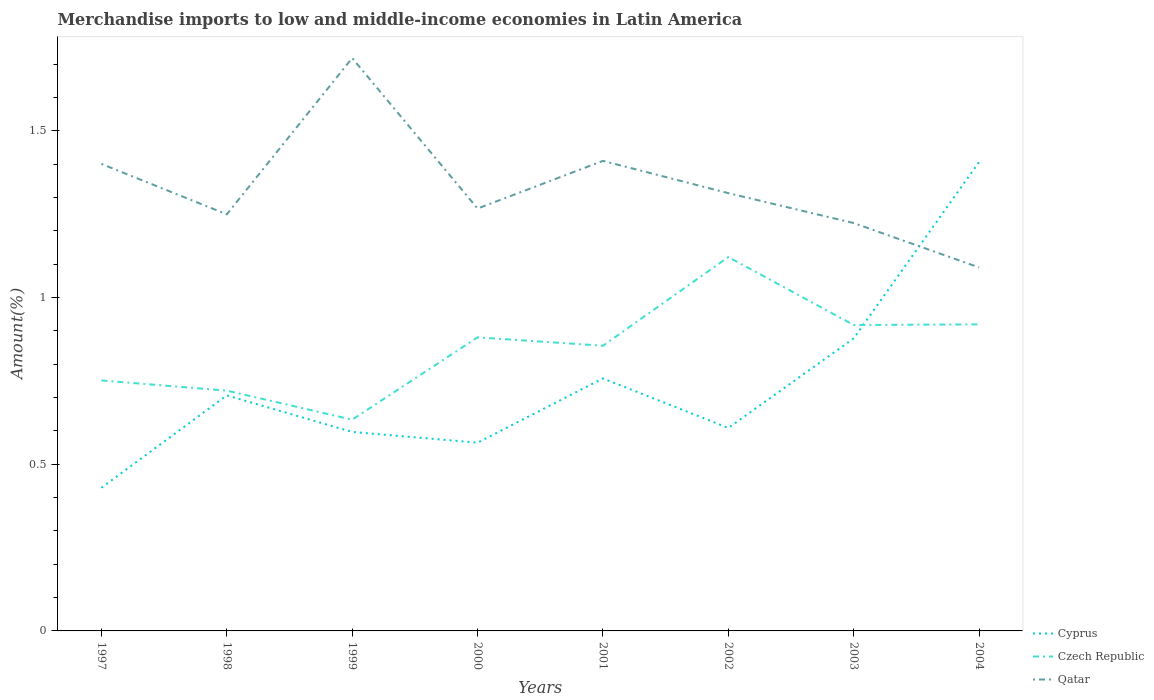Is the number of lines equal to the number of legend labels?
Offer a very short reply. Yes. Across all years, what is the maximum percentage of amount earned from merchandise imports in Qatar?
Offer a terse response. 1.09. What is the total percentage of amount earned from merchandise imports in Czech Republic in the graph?
Provide a succinct answer. -0.17. What is the difference between the highest and the second highest percentage of amount earned from merchandise imports in Cyprus?
Offer a very short reply. 0.98. What is the difference between the highest and the lowest percentage of amount earned from merchandise imports in Czech Republic?
Provide a succinct answer. 5. Is the percentage of amount earned from merchandise imports in Cyprus strictly greater than the percentage of amount earned from merchandise imports in Qatar over the years?
Keep it short and to the point. No. Does the graph contain any zero values?
Provide a succinct answer. No. Where does the legend appear in the graph?
Offer a terse response. Bottom right. How many legend labels are there?
Your response must be concise. 3. How are the legend labels stacked?
Your answer should be compact. Vertical. What is the title of the graph?
Make the answer very short. Merchandise imports to low and middle-income economies in Latin America. What is the label or title of the Y-axis?
Your answer should be very brief. Amount(%). What is the Amount(%) of Cyprus in 1997?
Give a very brief answer. 0.43. What is the Amount(%) in Czech Republic in 1997?
Offer a very short reply. 0.75. What is the Amount(%) of Qatar in 1997?
Your answer should be very brief. 1.4. What is the Amount(%) of Cyprus in 1998?
Give a very brief answer. 0.71. What is the Amount(%) of Czech Republic in 1998?
Your answer should be very brief. 0.72. What is the Amount(%) in Qatar in 1998?
Your answer should be compact. 1.25. What is the Amount(%) of Cyprus in 1999?
Keep it short and to the point. 0.6. What is the Amount(%) in Czech Republic in 1999?
Offer a terse response. 0.63. What is the Amount(%) in Qatar in 1999?
Offer a very short reply. 1.72. What is the Amount(%) in Cyprus in 2000?
Provide a succinct answer. 0.56. What is the Amount(%) of Czech Republic in 2000?
Your answer should be compact. 0.88. What is the Amount(%) of Qatar in 2000?
Give a very brief answer. 1.27. What is the Amount(%) in Cyprus in 2001?
Your answer should be compact. 0.76. What is the Amount(%) in Czech Republic in 2001?
Provide a short and direct response. 0.86. What is the Amount(%) in Qatar in 2001?
Offer a very short reply. 1.41. What is the Amount(%) of Cyprus in 2002?
Make the answer very short. 0.61. What is the Amount(%) in Czech Republic in 2002?
Give a very brief answer. 1.12. What is the Amount(%) in Qatar in 2002?
Offer a terse response. 1.31. What is the Amount(%) in Cyprus in 2003?
Give a very brief answer. 0.88. What is the Amount(%) in Czech Republic in 2003?
Provide a short and direct response. 0.92. What is the Amount(%) in Qatar in 2003?
Provide a succinct answer. 1.22. What is the Amount(%) of Cyprus in 2004?
Give a very brief answer. 1.41. What is the Amount(%) of Czech Republic in 2004?
Provide a succinct answer. 0.92. What is the Amount(%) in Qatar in 2004?
Offer a terse response. 1.09. Across all years, what is the maximum Amount(%) of Cyprus?
Provide a short and direct response. 1.41. Across all years, what is the maximum Amount(%) of Czech Republic?
Make the answer very short. 1.12. Across all years, what is the maximum Amount(%) of Qatar?
Keep it short and to the point. 1.72. Across all years, what is the minimum Amount(%) in Cyprus?
Offer a terse response. 0.43. Across all years, what is the minimum Amount(%) in Czech Republic?
Provide a short and direct response. 0.63. Across all years, what is the minimum Amount(%) in Qatar?
Provide a short and direct response. 1.09. What is the total Amount(%) in Cyprus in the graph?
Offer a very short reply. 5.95. What is the total Amount(%) in Czech Republic in the graph?
Offer a terse response. 6.8. What is the total Amount(%) of Qatar in the graph?
Offer a very short reply. 10.67. What is the difference between the Amount(%) in Cyprus in 1997 and that in 1998?
Keep it short and to the point. -0.28. What is the difference between the Amount(%) in Czech Republic in 1997 and that in 1998?
Offer a terse response. 0.03. What is the difference between the Amount(%) in Qatar in 1997 and that in 1998?
Provide a short and direct response. 0.15. What is the difference between the Amount(%) in Cyprus in 1997 and that in 1999?
Your answer should be compact. -0.17. What is the difference between the Amount(%) in Czech Republic in 1997 and that in 1999?
Provide a short and direct response. 0.12. What is the difference between the Amount(%) of Qatar in 1997 and that in 1999?
Your answer should be compact. -0.32. What is the difference between the Amount(%) of Cyprus in 1997 and that in 2000?
Your answer should be very brief. -0.14. What is the difference between the Amount(%) of Czech Republic in 1997 and that in 2000?
Give a very brief answer. -0.13. What is the difference between the Amount(%) in Qatar in 1997 and that in 2000?
Give a very brief answer. 0.13. What is the difference between the Amount(%) of Cyprus in 1997 and that in 2001?
Keep it short and to the point. -0.33. What is the difference between the Amount(%) in Czech Republic in 1997 and that in 2001?
Give a very brief answer. -0.1. What is the difference between the Amount(%) in Qatar in 1997 and that in 2001?
Make the answer very short. -0.01. What is the difference between the Amount(%) in Cyprus in 1997 and that in 2002?
Your answer should be very brief. -0.18. What is the difference between the Amount(%) of Czech Republic in 1997 and that in 2002?
Provide a short and direct response. -0.37. What is the difference between the Amount(%) of Qatar in 1997 and that in 2002?
Make the answer very short. 0.09. What is the difference between the Amount(%) of Cyprus in 1997 and that in 2003?
Ensure brevity in your answer.  -0.45. What is the difference between the Amount(%) in Czech Republic in 1997 and that in 2003?
Provide a succinct answer. -0.17. What is the difference between the Amount(%) of Qatar in 1997 and that in 2003?
Keep it short and to the point. 0.18. What is the difference between the Amount(%) of Cyprus in 1997 and that in 2004?
Offer a very short reply. -0.98. What is the difference between the Amount(%) in Czech Republic in 1997 and that in 2004?
Ensure brevity in your answer.  -0.17. What is the difference between the Amount(%) in Qatar in 1997 and that in 2004?
Ensure brevity in your answer.  0.31. What is the difference between the Amount(%) in Cyprus in 1998 and that in 1999?
Provide a short and direct response. 0.11. What is the difference between the Amount(%) of Czech Republic in 1998 and that in 1999?
Provide a short and direct response. 0.09. What is the difference between the Amount(%) of Qatar in 1998 and that in 1999?
Your answer should be very brief. -0.47. What is the difference between the Amount(%) in Cyprus in 1998 and that in 2000?
Your answer should be very brief. 0.14. What is the difference between the Amount(%) in Czech Republic in 1998 and that in 2000?
Ensure brevity in your answer.  -0.16. What is the difference between the Amount(%) of Qatar in 1998 and that in 2000?
Your response must be concise. -0.02. What is the difference between the Amount(%) of Cyprus in 1998 and that in 2001?
Offer a terse response. -0.05. What is the difference between the Amount(%) of Czech Republic in 1998 and that in 2001?
Keep it short and to the point. -0.13. What is the difference between the Amount(%) of Qatar in 1998 and that in 2001?
Offer a terse response. -0.16. What is the difference between the Amount(%) in Cyprus in 1998 and that in 2002?
Provide a succinct answer. 0.1. What is the difference between the Amount(%) in Czech Republic in 1998 and that in 2002?
Provide a succinct answer. -0.4. What is the difference between the Amount(%) in Qatar in 1998 and that in 2002?
Your answer should be very brief. -0.06. What is the difference between the Amount(%) of Cyprus in 1998 and that in 2003?
Make the answer very short. -0.17. What is the difference between the Amount(%) in Czech Republic in 1998 and that in 2003?
Make the answer very short. -0.2. What is the difference between the Amount(%) of Qatar in 1998 and that in 2003?
Make the answer very short. 0.03. What is the difference between the Amount(%) in Cyprus in 1998 and that in 2004?
Keep it short and to the point. -0.7. What is the difference between the Amount(%) in Czech Republic in 1998 and that in 2004?
Ensure brevity in your answer.  -0.2. What is the difference between the Amount(%) in Qatar in 1998 and that in 2004?
Offer a terse response. 0.16. What is the difference between the Amount(%) in Cyprus in 1999 and that in 2000?
Provide a short and direct response. 0.03. What is the difference between the Amount(%) of Czech Republic in 1999 and that in 2000?
Offer a very short reply. -0.25. What is the difference between the Amount(%) of Qatar in 1999 and that in 2000?
Provide a succinct answer. 0.45. What is the difference between the Amount(%) in Cyprus in 1999 and that in 2001?
Give a very brief answer. -0.16. What is the difference between the Amount(%) in Czech Republic in 1999 and that in 2001?
Your response must be concise. -0.22. What is the difference between the Amount(%) in Qatar in 1999 and that in 2001?
Offer a terse response. 0.31. What is the difference between the Amount(%) in Cyprus in 1999 and that in 2002?
Provide a succinct answer. -0.01. What is the difference between the Amount(%) in Czech Republic in 1999 and that in 2002?
Your answer should be compact. -0.49. What is the difference between the Amount(%) of Qatar in 1999 and that in 2002?
Keep it short and to the point. 0.41. What is the difference between the Amount(%) in Cyprus in 1999 and that in 2003?
Your answer should be very brief. -0.28. What is the difference between the Amount(%) in Czech Republic in 1999 and that in 2003?
Offer a very short reply. -0.28. What is the difference between the Amount(%) of Qatar in 1999 and that in 2003?
Make the answer very short. 0.49. What is the difference between the Amount(%) of Cyprus in 1999 and that in 2004?
Make the answer very short. -0.81. What is the difference between the Amount(%) of Czech Republic in 1999 and that in 2004?
Keep it short and to the point. -0.29. What is the difference between the Amount(%) in Qatar in 1999 and that in 2004?
Offer a very short reply. 0.63. What is the difference between the Amount(%) of Cyprus in 2000 and that in 2001?
Provide a short and direct response. -0.19. What is the difference between the Amount(%) of Czech Republic in 2000 and that in 2001?
Offer a very short reply. 0.03. What is the difference between the Amount(%) of Qatar in 2000 and that in 2001?
Offer a terse response. -0.14. What is the difference between the Amount(%) of Cyprus in 2000 and that in 2002?
Offer a very short reply. -0.04. What is the difference between the Amount(%) of Czech Republic in 2000 and that in 2002?
Provide a succinct answer. -0.24. What is the difference between the Amount(%) of Qatar in 2000 and that in 2002?
Make the answer very short. -0.05. What is the difference between the Amount(%) of Cyprus in 2000 and that in 2003?
Offer a very short reply. -0.31. What is the difference between the Amount(%) in Czech Republic in 2000 and that in 2003?
Your answer should be very brief. -0.04. What is the difference between the Amount(%) of Qatar in 2000 and that in 2003?
Offer a very short reply. 0.04. What is the difference between the Amount(%) in Cyprus in 2000 and that in 2004?
Your response must be concise. -0.84. What is the difference between the Amount(%) of Czech Republic in 2000 and that in 2004?
Give a very brief answer. -0.04. What is the difference between the Amount(%) of Qatar in 2000 and that in 2004?
Provide a short and direct response. 0.18. What is the difference between the Amount(%) of Cyprus in 2001 and that in 2002?
Your response must be concise. 0.15. What is the difference between the Amount(%) in Czech Republic in 2001 and that in 2002?
Provide a short and direct response. -0.27. What is the difference between the Amount(%) of Qatar in 2001 and that in 2002?
Keep it short and to the point. 0.1. What is the difference between the Amount(%) of Cyprus in 2001 and that in 2003?
Your response must be concise. -0.12. What is the difference between the Amount(%) of Czech Republic in 2001 and that in 2003?
Ensure brevity in your answer.  -0.06. What is the difference between the Amount(%) of Qatar in 2001 and that in 2003?
Your answer should be very brief. 0.19. What is the difference between the Amount(%) in Cyprus in 2001 and that in 2004?
Your response must be concise. -0.65. What is the difference between the Amount(%) in Czech Republic in 2001 and that in 2004?
Your response must be concise. -0.06. What is the difference between the Amount(%) in Qatar in 2001 and that in 2004?
Your answer should be compact. 0.32. What is the difference between the Amount(%) in Cyprus in 2002 and that in 2003?
Ensure brevity in your answer.  -0.27. What is the difference between the Amount(%) of Czech Republic in 2002 and that in 2003?
Keep it short and to the point. 0.2. What is the difference between the Amount(%) of Qatar in 2002 and that in 2003?
Offer a very short reply. 0.09. What is the difference between the Amount(%) in Cyprus in 2002 and that in 2004?
Give a very brief answer. -0.8. What is the difference between the Amount(%) of Czech Republic in 2002 and that in 2004?
Offer a very short reply. 0.2. What is the difference between the Amount(%) in Qatar in 2002 and that in 2004?
Ensure brevity in your answer.  0.22. What is the difference between the Amount(%) of Cyprus in 2003 and that in 2004?
Give a very brief answer. -0.53. What is the difference between the Amount(%) in Czech Republic in 2003 and that in 2004?
Keep it short and to the point. -0. What is the difference between the Amount(%) in Qatar in 2003 and that in 2004?
Your answer should be compact. 0.13. What is the difference between the Amount(%) in Cyprus in 1997 and the Amount(%) in Czech Republic in 1998?
Keep it short and to the point. -0.29. What is the difference between the Amount(%) of Cyprus in 1997 and the Amount(%) of Qatar in 1998?
Make the answer very short. -0.82. What is the difference between the Amount(%) of Czech Republic in 1997 and the Amount(%) of Qatar in 1998?
Offer a terse response. -0.5. What is the difference between the Amount(%) in Cyprus in 1997 and the Amount(%) in Czech Republic in 1999?
Provide a succinct answer. -0.2. What is the difference between the Amount(%) in Cyprus in 1997 and the Amount(%) in Qatar in 1999?
Ensure brevity in your answer.  -1.29. What is the difference between the Amount(%) of Czech Republic in 1997 and the Amount(%) of Qatar in 1999?
Ensure brevity in your answer.  -0.97. What is the difference between the Amount(%) in Cyprus in 1997 and the Amount(%) in Czech Republic in 2000?
Offer a very short reply. -0.45. What is the difference between the Amount(%) in Cyprus in 1997 and the Amount(%) in Qatar in 2000?
Your answer should be compact. -0.84. What is the difference between the Amount(%) in Czech Republic in 1997 and the Amount(%) in Qatar in 2000?
Offer a terse response. -0.52. What is the difference between the Amount(%) in Cyprus in 1997 and the Amount(%) in Czech Republic in 2001?
Keep it short and to the point. -0.43. What is the difference between the Amount(%) of Cyprus in 1997 and the Amount(%) of Qatar in 2001?
Your answer should be compact. -0.98. What is the difference between the Amount(%) of Czech Republic in 1997 and the Amount(%) of Qatar in 2001?
Ensure brevity in your answer.  -0.66. What is the difference between the Amount(%) of Cyprus in 1997 and the Amount(%) of Czech Republic in 2002?
Provide a succinct answer. -0.69. What is the difference between the Amount(%) in Cyprus in 1997 and the Amount(%) in Qatar in 2002?
Your answer should be compact. -0.88. What is the difference between the Amount(%) of Czech Republic in 1997 and the Amount(%) of Qatar in 2002?
Your answer should be very brief. -0.56. What is the difference between the Amount(%) in Cyprus in 1997 and the Amount(%) in Czech Republic in 2003?
Ensure brevity in your answer.  -0.49. What is the difference between the Amount(%) in Cyprus in 1997 and the Amount(%) in Qatar in 2003?
Your answer should be very brief. -0.79. What is the difference between the Amount(%) in Czech Republic in 1997 and the Amount(%) in Qatar in 2003?
Your answer should be very brief. -0.47. What is the difference between the Amount(%) in Cyprus in 1997 and the Amount(%) in Czech Republic in 2004?
Your answer should be compact. -0.49. What is the difference between the Amount(%) in Cyprus in 1997 and the Amount(%) in Qatar in 2004?
Provide a succinct answer. -0.66. What is the difference between the Amount(%) of Czech Republic in 1997 and the Amount(%) of Qatar in 2004?
Make the answer very short. -0.34. What is the difference between the Amount(%) of Cyprus in 1998 and the Amount(%) of Czech Republic in 1999?
Offer a terse response. 0.07. What is the difference between the Amount(%) in Cyprus in 1998 and the Amount(%) in Qatar in 1999?
Your answer should be very brief. -1.01. What is the difference between the Amount(%) of Czech Republic in 1998 and the Amount(%) of Qatar in 1999?
Offer a very short reply. -1. What is the difference between the Amount(%) in Cyprus in 1998 and the Amount(%) in Czech Republic in 2000?
Make the answer very short. -0.17. What is the difference between the Amount(%) in Cyprus in 1998 and the Amount(%) in Qatar in 2000?
Make the answer very short. -0.56. What is the difference between the Amount(%) in Czech Republic in 1998 and the Amount(%) in Qatar in 2000?
Your answer should be very brief. -0.55. What is the difference between the Amount(%) of Cyprus in 1998 and the Amount(%) of Czech Republic in 2001?
Keep it short and to the point. -0.15. What is the difference between the Amount(%) of Cyprus in 1998 and the Amount(%) of Qatar in 2001?
Provide a succinct answer. -0.7. What is the difference between the Amount(%) in Czech Republic in 1998 and the Amount(%) in Qatar in 2001?
Your answer should be compact. -0.69. What is the difference between the Amount(%) in Cyprus in 1998 and the Amount(%) in Czech Republic in 2002?
Keep it short and to the point. -0.41. What is the difference between the Amount(%) of Cyprus in 1998 and the Amount(%) of Qatar in 2002?
Offer a very short reply. -0.61. What is the difference between the Amount(%) in Czech Republic in 1998 and the Amount(%) in Qatar in 2002?
Offer a very short reply. -0.59. What is the difference between the Amount(%) in Cyprus in 1998 and the Amount(%) in Czech Republic in 2003?
Offer a very short reply. -0.21. What is the difference between the Amount(%) of Cyprus in 1998 and the Amount(%) of Qatar in 2003?
Your answer should be compact. -0.52. What is the difference between the Amount(%) of Czech Republic in 1998 and the Amount(%) of Qatar in 2003?
Keep it short and to the point. -0.5. What is the difference between the Amount(%) in Cyprus in 1998 and the Amount(%) in Czech Republic in 2004?
Your response must be concise. -0.21. What is the difference between the Amount(%) in Cyprus in 1998 and the Amount(%) in Qatar in 2004?
Ensure brevity in your answer.  -0.38. What is the difference between the Amount(%) of Czech Republic in 1998 and the Amount(%) of Qatar in 2004?
Ensure brevity in your answer.  -0.37. What is the difference between the Amount(%) of Cyprus in 1999 and the Amount(%) of Czech Republic in 2000?
Your answer should be very brief. -0.28. What is the difference between the Amount(%) in Cyprus in 1999 and the Amount(%) in Qatar in 2000?
Provide a short and direct response. -0.67. What is the difference between the Amount(%) of Czech Republic in 1999 and the Amount(%) of Qatar in 2000?
Your answer should be compact. -0.63. What is the difference between the Amount(%) of Cyprus in 1999 and the Amount(%) of Czech Republic in 2001?
Your response must be concise. -0.26. What is the difference between the Amount(%) in Cyprus in 1999 and the Amount(%) in Qatar in 2001?
Give a very brief answer. -0.81. What is the difference between the Amount(%) in Czech Republic in 1999 and the Amount(%) in Qatar in 2001?
Your response must be concise. -0.78. What is the difference between the Amount(%) of Cyprus in 1999 and the Amount(%) of Czech Republic in 2002?
Provide a succinct answer. -0.52. What is the difference between the Amount(%) in Cyprus in 1999 and the Amount(%) in Qatar in 2002?
Offer a terse response. -0.72. What is the difference between the Amount(%) in Czech Republic in 1999 and the Amount(%) in Qatar in 2002?
Offer a terse response. -0.68. What is the difference between the Amount(%) in Cyprus in 1999 and the Amount(%) in Czech Republic in 2003?
Make the answer very short. -0.32. What is the difference between the Amount(%) of Cyprus in 1999 and the Amount(%) of Qatar in 2003?
Your answer should be very brief. -0.63. What is the difference between the Amount(%) of Czech Republic in 1999 and the Amount(%) of Qatar in 2003?
Provide a short and direct response. -0.59. What is the difference between the Amount(%) of Cyprus in 1999 and the Amount(%) of Czech Republic in 2004?
Ensure brevity in your answer.  -0.32. What is the difference between the Amount(%) in Cyprus in 1999 and the Amount(%) in Qatar in 2004?
Make the answer very short. -0.49. What is the difference between the Amount(%) in Czech Republic in 1999 and the Amount(%) in Qatar in 2004?
Your answer should be very brief. -0.46. What is the difference between the Amount(%) in Cyprus in 2000 and the Amount(%) in Czech Republic in 2001?
Ensure brevity in your answer.  -0.29. What is the difference between the Amount(%) in Cyprus in 2000 and the Amount(%) in Qatar in 2001?
Your answer should be very brief. -0.84. What is the difference between the Amount(%) in Czech Republic in 2000 and the Amount(%) in Qatar in 2001?
Ensure brevity in your answer.  -0.53. What is the difference between the Amount(%) of Cyprus in 2000 and the Amount(%) of Czech Republic in 2002?
Provide a short and direct response. -0.56. What is the difference between the Amount(%) of Cyprus in 2000 and the Amount(%) of Qatar in 2002?
Offer a terse response. -0.75. What is the difference between the Amount(%) of Czech Republic in 2000 and the Amount(%) of Qatar in 2002?
Give a very brief answer. -0.43. What is the difference between the Amount(%) of Cyprus in 2000 and the Amount(%) of Czech Republic in 2003?
Offer a terse response. -0.35. What is the difference between the Amount(%) of Cyprus in 2000 and the Amount(%) of Qatar in 2003?
Your answer should be compact. -0.66. What is the difference between the Amount(%) of Czech Republic in 2000 and the Amount(%) of Qatar in 2003?
Provide a succinct answer. -0.34. What is the difference between the Amount(%) in Cyprus in 2000 and the Amount(%) in Czech Republic in 2004?
Make the answer very short. -0.35. What is the difference between the Amount(%) of Cyprus in 2000 and the Amount(%) of Qatar in 2004?
Your answer should be very brief. -0.53. What is the difference between the Amount(%) in Czech Republic in 2000 and the Amount(%) in Qatar in 2004?
Give a very brief answer. -0.21. What is the difference between the Amount(%) of Cyprus in 2001 and the Amount(%) of Czech Republic in 2002?
Offer a terse response. -0.36. What is the difference between the Amount(%) of Cyprus in 2001 and the Amount(%) of Qatar in 2002?
Offer a terse response. -0.56. What is the difference between the Amount(%) in Czech Republic in 2001 and the Amount(%) in Qatar in 2002?
Ensure brevity in your answer.  -0.46. What is the difference between the Amount(%) of Cyprus in 2001 and the Amount(%) of Czech Republic in 2003?
Your response must be concise. -0.16. What is the difference between the Amount(%) in Cyprus in 2001 and the Amount(%) in Qatar in 2003?
Make the answer very short. -0.47. What is the difference between the Amount(%) of Czech Republic in 2001 and the Amount(%) of Qatar in 2003?
Offer a terse response. -0.37. What is the difference between the Amount(%) of Cyprus in 2001 and the Amount(%) of Czech Republic in 2004?
Ensure brevity in your answer.  -0.16. What is the difference between the Amount(%) in Cyprus in 2001 and the Amount(%) in Qatar in 2004?
Provide a succinct answer. -0.33. What is the difference between the Amount(%) in Czech Republic in 2001 and the Amount(%) in Qatar in 2004?
Make the answer very short. -0.23. What is the difference between the Amount(%) in Cyprus in 2002 and the Amount(%) in Czech Republic in 2003?
Your answer should be compact. -0.31. What is the difference between the Amount(%) in Cyprus in 2002 and the Amount(%) in Qatar in 2003?
Offer a very short reply. -0.61. What is the difference between the Amount(%) in Czech Republic in 2002 and the Amount(%) in Qatar in 2003?
Make the answer very short. -0.1. What is the difference between the Amount(%) in Cyprus in 2002 and the Amount(%) in Czech Republic in 2004?
Your answer should be very brief. -0.31. What is the difference between the Amount(%) in Cyprus in 2002 and the Amount(%) in Qatar in 2004?
Give a very brief answer. -0.48. What is the difference between the Amount(%) in Czech Republic in 2002 and the Amount(%) in Qatar in 2004?
Your answer should be compact. 0.03. What is the difference between the Amount(%) of Cyprus in 2003 and the Amount(%) of Czech Republic in 2004?
Offer a very short reply. -0.04. What is the difference between the Amount(%) in Cyprus in 2003 and the Amount(%) in Qatar in 2004?
Keep it short and to the point. -0.21. What is the difference between the Amount(%) of Czech Republic in 2003 and the Amount(%) of Qatar in 2004?
Provide a succinct answer. -0.17. What is the average Amount(%) in Cyprus per year?
Offer a terse response. 0.74. What is the average Amount(%) in Czech Republic per year?
Your response must be concise. 0.85. What is the average Amount(%) of Qatar per year?
Your response must be concise. 1.33. In the year 1997, what is the difference between the Amount(%) of Cyprus and Amount(%) of Czech Republic?
Make the answer very short. -0.32. In the year 1997, what is the difference between the Amount(%) of Cyprus and Amount(%) of Qatar?
Keep it short and to the point. -0.97. In the year 1997, what is the difference between the Amount(%) of Czech Republic and Amount(%) of Qatar?
Your answer should be very brief. -0.65. In the year 1998, what is the difference between the Amount(%) of Cyprus and Amount(%) of Czech Republic?
Your response must be concise. -0.01. In the year 1998, what is the difference between the Amount(%) of Cyprus and Amount(%) of Qatar?
Make the answer very short. -0.54. In the year 1998, what is the difference between the Amount(%) of Czech Republic and Amount(%) of Qatar?
Offer a terse response. -0.53. In the year 1999, what is the difference between the Amount(%) of Cyprus and Amount(%) of Czech Republic?
Keep it short and to the point. -0.04. In the year 1999, what is the difference between the Amount(%) of Cyprus and Amount(%) of Qatar?
Provide a succinct answer. -1.12. In the year 1999, what is the difference between the Amount(%) of Czech Republic and Amount(%) of Qatar?
Keep it short and to the point. -1.08. In the year 2000, what is the difference between the Amount(%) in Cyprus and Amount(%) in Czech Republic?
Provide a succinct answer. -0.32. In the year 2000, what is the difference between the Amount(%) of Cyprus and Amount(%) of Qatar?
Offer a terse response. -0.7. In the year 2000, what is the difference between the Amount(%) of Czech Republic and Amount(%) of Qatar?
Your answer should be very brief. -0.39. In the year 2001, what is the difference between the Amount(%) of Cyprus and Amount(%) of Czech Republic?
Your response must be concise. -0.1. In the year 2001, what is the difference between the Amount(%) in Cyprus and Amount(%) in Qatar?
Give a very brief answer. -0.65. In the year 2001, what is the difference between the Amount(%) of Czech Republic and Amount(%) of Qatar?
Provide a short and direct response. -0.55. In the year 2002, what is the difference between the Amount(%) in Cyprus and Amount(%) in Czech Republic?
Offer a terse response. -0.51. In the year 2002, what is the difference between the Amount(%) in Cyprus and Amount(%) in Qatar?
Offer a terse response. -0.7. In the year 2002, what is the difference between the Amount(%) in Czech Republic and Amount(%) in Qatar?
Your answer should be compact. -0.19. In the year 2003, what is the difference between the Amount(%) of Cyprus and Amount(%) of Czech Republic?
Offer a terse response. -0.04. In the year 2003, what is the difference between the Amount(%) of Cyprus and Amount(%) of Qatar?
Offer a terse response. -0.35. In the year 2003, what is the difference between the Amount(%) in Czech Republic and Amount(%) in Qatar?
Your response must be concise. -0.31. In the year 2004, what is the difference between the Amount(%) of Cyprus and Amount(%) of Czech Republic?
Offer a terse response. 0.49. In the year 2004, what is the difference between the Amount(%) in Cyprus and Amount(%) in Qatar?
Give a very brief answer. 0.32. In the year 2004, what is the difference between the Amount(%) in Czech Republic and Amount(%) in Qatar?
Provide a succinct answer. -0.17. What is the ratio of the Amount(%) in Cyprus in 1997 to that in 1998?
Give a very brief answer. 0.61. What is the ratio of the Amount(%) in Czech Republic in 1997 to that in 1998?
Ensure brevity in your answer.  1.04. What is the ratio of the Amount(%) in Qatar in 1997 to that in 1998?
Provide a succinct answer. 1.12. What is the ratio of the Amount(%) of Cyprus in 1997 to that in 1999?
Make the answer very short. 0.72. What is the ratio of the Amount(%) of Czech Republic in 1997 to that in 1999?
Provide a short and direct response. 1.19. What is the ratio of the Amount(%) of Qatar in 1997 to that in 1999?
Provide a short and direct response. 0.82. What is the ratio of the Amount(%) in Cyprus in 1997 to that in 2000?
Give a very brief answer. 0.76. What is the ratio of the Amount(%) of Czech Republic in 1997 to that in 2000?
Keep it short and to the point. 0.85. What is the ratio of the Amount(%) of Qatar in 1997 to that in 2000?
Offer a terse response. 1.11. What is the ratio of the Amount(%) of Cyprus in 1997 to that in 2001?
Offer a very short reply. 0.57. What is the ratio of the Amount(%) of Czech Republic in 1997 to that in 2001?
Provide a succinct answer. 0.88. What is the ratio of the Amount(%) in Cyprus in 1997 to that in 2002?
Give a very brief answer. 0.71. What is the ratio of the Amount(%) in Czech Republic in 1997 to that in 2002?
Offer a terse response. 0.67. What is the ratio of the Amount(%) of Qatar in 1997 to that in 2002?
Keep it short and to the point. 1.07. What is the ratio of the Amount(%) in Cyprus in 1997 to that in 2003?
Give a very brief answer. 0.49. What is the ratio of the Amount(%) in Czech Republic in 1997 to that in 2003?
Offer a very short reply. 0.82. What is the ratio of the Amount(%) in Qatar in 1997 to that in 2003?
Your response must be concise. 1.15. What is the ratio of the Amount(%) of Cyprus in 1997 to that in 2004?
Offer a very short reply. 0.31. What is the ratio of the Amount(%) in Czech Republic in 1997 to that in 2004?
Your response must be concise. 0.82. What is the ratio of the Amount(%) in Qatar in 1997 to that in 2004?
Offer a terse response. 1.28. What is the ratio of the Amount(%) in Cyprus in 1998 to that in 1999?
Provide a short and direct response. 1.18. What is the ratio of the Amount(%) of Czech Republic in 1998 to that in 1999?
Your answer should be very brief. 1.14. What is the ratio of the Amount(%) in Qatar in 1998 to that in 1999?
Give a very brief answer. 0.73. What is the ratio of the Amount(%) of Cyprus in 1998 to that in 2000?
Keep it short and to the point. 1.25. What is the ratio of the Amount(%) in Czech Republic in 1998 to that in 2000?
Your answer should be compact. 0.82. What is the ratio of the Amount(%) in Qatar in 1998 to that in 2000?
Ensure brevity in your answer.  0.99. What is the ratio of the Amount(%) of Cyprus in 1998 to that in 2001?
Give a very brief answer. 0.93. What is the ratio of the Amount(%) of Czech Republic in 1998 to that in 2001?
Provide a succinct answer. 0.84. What is the ratio of the Amount(%) in Qatar in 1998 to that in 2001?
Give a very brief answer. 0.89. What is the ratio of the Amount(%) of Cyprus in 1998 to that in 2002?
Keep it short and to the point. 1.16. What is the ratio of the Amount(%) in Czech Republic in 1998 to that in 2002?
Your response must be concise. 0.64. What is the ratio of the Amount(%) in Qatar in 1998 to that in 2002?
Keep it short and to the point. 0.95. What is the ratio of the Amount(%) in Cyprus in 1998 to that in 2003?
Offer a very short reply. 0.81. What is the ratio of the Amount(%) in Czech Republic in 1998 to that in 2003?
Your response must be concise. 0.79. What is the ratio of the Amount(%) of Qatar in 1998 to that in 2003?
Give a very brief answer. 1.02. What is the ratio of the Amount(%) in Cyprus in 1998 to that in 2004?
Your response must be concise. 0.5. What is the ratio of the Amount(%) in Czech Republic in 1998 to that in 2004?
Offer a very short reply. 0.78. What is the ratio of the Amount(%) in Qatar in 1998 to that in 2004?
Offer a very short reply. 1.15. What is the ratio of the Amount(%) of Cyprus in 1999 to that in 2000?
Ensure brevity in your answer.  1.06. What is the ratio of the Amount(%) in Czech Republic in 1999 to that in 2000?
Keep it short and to the point. 0.72. What is the ratio of the Amount(%) in Qatar in 1999 to that in 2000?
Your response must be concise. 1.36. What is the ratio of the Amount(%) in Cyprus in 1999 to that in 2001?
Offer a very short reply. 0.79. What is the ratio of the Amount(%) of Czech Republic in 1999 to that in 2001?
Ensure brevity in your answer.  0.74. What is the ratio of the Amount(%) of Qatar in 1999 to that in 2001?
Provide a succinct answer. 1.22. What is the ratio of the Amount(%) in Cyprus in 1999 to that in 2002?
Ensure brevity in your answer.  0.98. What is the ratio of the Amount(%) of Czech Republic in 1999 to that in 2002?
Offer a terse response. 0.56. What is the ratio of the Amount(%) of Qatar in 1999 to that in 2002?
Ensure brevity in your answer.  1.31. What is the ratio of the Amount(%) in Cyprus in 1999 to that in 2003?
Offer a terse response. 0.68. What is the ratio of the Amount(%) in Czech Republic in 1999 to that in 2003?
Provide a short and direct response. 0.69. What is the ratio of the Amount(%) in Qatar in 1999 to that in 2003?
Your answer should be very brief. 1.4. What is the ratio of the Amount(%) in Cyprus in 1999 to that in 2004?
Provide a short and direct response. 0.42. What is the ratio of the Amount(%) of Czech Republic in 1999 to that in 2004?
Offer a very short reply. 0.69. What is the ratio of the Amount(%) in Qatar in 1999 to that in 2004?
Provide a succinct answer. 1.58. What is the ratio of the Amount(%) in Cyprus in 2000 to that in 2001?
Your response must be concise. 0.75. What is the ratio of the Amount(%) of Czech Republic in 2000 to that in 2001?
Provide a succinct answer. 1.03. What is the ratio of the Amount(%) of Qatar in 2000 to that in 2001?
Your response must be concise. 0.9. What is the ratio of the Amount(%) in Cyprus in 2000 to that in 2002?
Provide a succinct answer. 0.93. What is the ratio of the Amount(%) of Czech Republic in 2000 to that in 2002?
Ensure brevity in your answer.  0.79. What is the ratio of the Amount(%) of Qatar in 2000 to that in 2002?
Your answer should be very brief. 0.96. What is the ratio of the Amount(%) of Cyprus in 2000 to that in 2003?
Offer a terse response. 0.64. What is the ratio of the Amount(%) in Czech Republic in 2000 to that in 2003?
Offer a terse response. 0.96. What is the ratio of the Amount(%) in Qatar in 2000 to that in 2003?
Give a very brief answer. 1.04. What is the ratio of the Amount(%) in Cyprus in 2000 to that in 2004?
Your response must be concise. 0.4. What is the ratio of the Amount(%) of Czech Republic in 2000 to that in 2004?
Ensure brevity in your answer.  0.96. What is the ratio of the Amount(%) in Qatar in 2000 to that in 2004?
Ensure brevity in your answer.  1.16. What is the ratio of the Amount(%) of Cyprus in 2001 to that in 2002?
Keep it short and to the point. 1.24. What is the ratio of the Amount(%) of Czech Republic in 2001 to that in 2002?
Provide a succinct answer. 0.76. What is the ratio of the Amount(%) of Qatar in 2001 to that in 2002?
Your answer should be very brief. 1.07. What is the ratio of the Amount(%) in Cyprus in 2001 to that in 2003?
Keep it short and to the point. 0.86. What is the ratio of the Amount(%) in Czech Republic in 2001 to that in 2003?
Offer a very short reply. 0.93. What is the ratio of the Amount(%) of Qatar in 2001 to that in 2003?
Your answer should be very brief. 1.15. What is the ratio of the Amount(%) in Cyprus in 2001 to that in 2004?
Give a very brief answer. 0.54. What is the ratio of the Amount(%) in Czech Republic in 2001 to that in 2004?
Keep it short and to the point. 0.93. What is the ratio of the Amount(%) of Qatar in 2001 to that in 2004?
Ensure brevity in your answer.  1.29. What is the ratio of the Amount(%) in Cyprus in 2002 to that in 2003?
Provide a short and direct response. 0.69. What is the ratio of the Amount(%) in Czech Republic in 2002 to that in 2003?
Your answer should be very brief. 1.22. What is the ratio of the Amount(%) in Qatar in 2002 to that in 2003?
Make the answer very short. 1.07. What is the ratio of the Amount(%) of Cyprus in 2002 to that in 2004?
Provide a succinct answer. 0.43. What is the ratio of the Amount(%) of Czech Republic in 2002 to that in 2004?
Your answer should be very brief. 1.22. What is the ratio of the Amount(%) in Qatar in 2002 to that in 2004?
Your response must be concise. 1.2. What is the ratio of the Amount(%) of Cyprus in 2003 to that in 2004?
Your response must be concise. 0.62. What is the ratio of the Amount(%) in Czech Republic in 2003 to that in 2004?
Provide a succinct answer. 1. What is the ratio of the Amount(%) of Qatar in 2003 to that in 2004?
Your response must be concise. 1.12. What is the difference between the highest and the second highest Amount(%) of Cyprus?
Provide a short and direct response. 0.53. What is the difference between the highest and the second highest Amount(%) of Czech Republic?
Give a very brief answer. 0.2. What is the difference between the highest and the second highest Amount(%) in Qatar?
Ensure brevity in your answer.  0.31. What is the difference between the highest and the lowest Amount(%) of Cyprus?
Make the answer very short. 0.98. What is the difference between the highest and the lowest Amount(%) in Czech Republic?
Make the answer very short. 0.49. What is the difference between the highest and the lowest Amount(%) of Qatar?
Offer a very short reply. 0.63. 